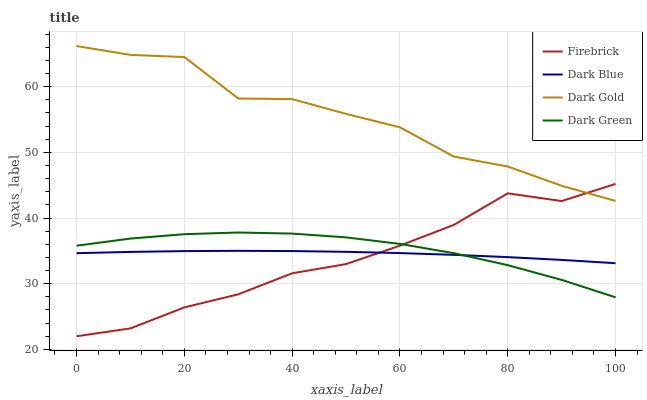Does Firebrick have the minimum area under the curve?
Answer yes or no. Yes. Does Dark Gold have the maximum area under the curve?
Answer yes or no. Yes. Does Dark Green have the minimum area under the curve?
Answer yes or no. No. Does Dark Green have the maximum area under the curve?
Answer yes or no. No. Is Dark Blue the smoothest?
Answer yes or no. Yes. Is Dark Gold the roughest?
Answer yes or no. Yes. Is Firebrick the smoothest?
Answer yes or no. No. Is Firebrick the roughest?
Answer yes or no. No. Does Firebrick have the lowest value?
Answer yes or no. Yes. Does Dark Green have the lowest value?
Answer yes or no. No. Does Dark Gold have the highest value?
Answer yes or no. Yes. Does Firebrick have the highest value?
Answer yes or no. No. Is Dark Green less than Dark Gold?
Answer yes or no. Yes. Is Dark Gold greater than Dark Blue?
Answer yes or no. Yes. Does Dark Blue intersect Firebrick?
Answer yes or no. Yes. Is Dark Blue less than Firebrick?
Answer yes or no. No. Is Dark Blue greater than Firebrick?
Answer yes or no. No. Does Dark Green intersect Dark Gold?
Answer yes or no. No. 